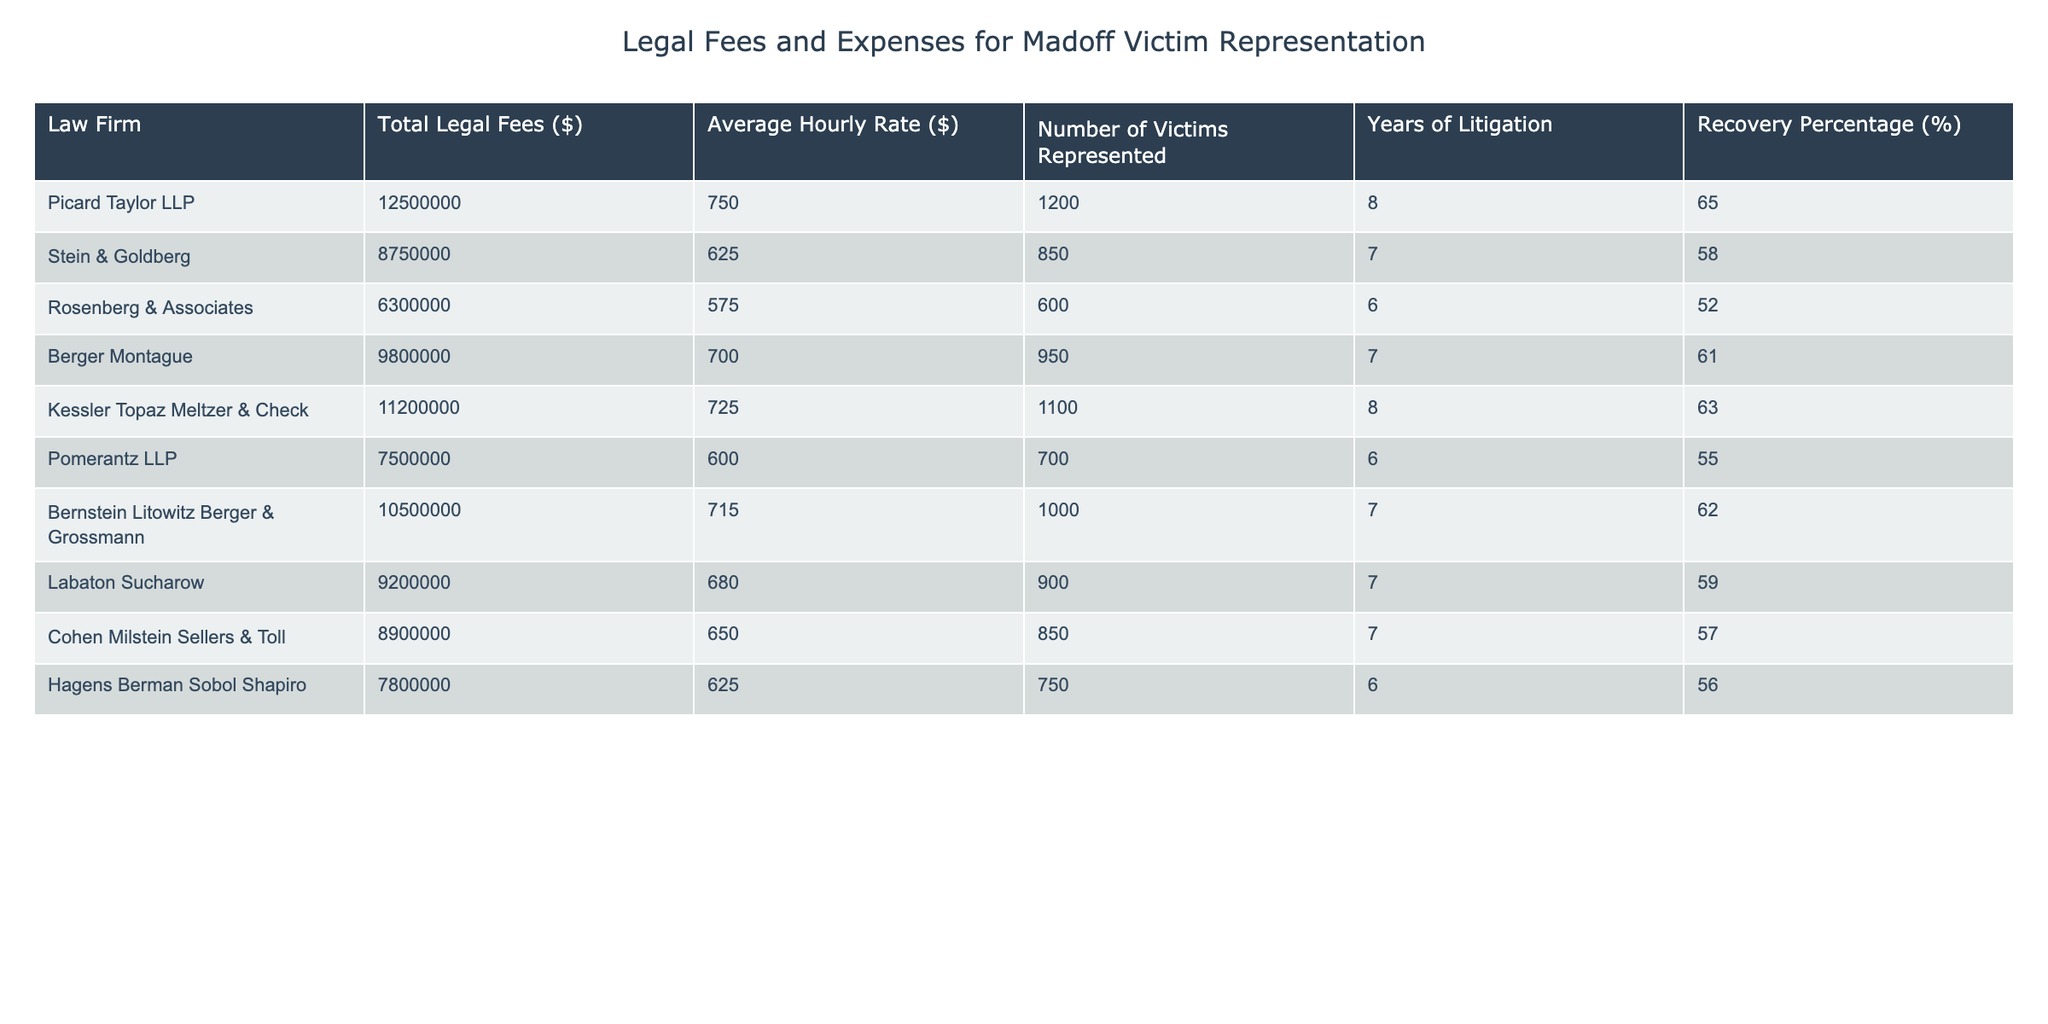What is the total legal fees charged by Picard Taylor LLP? The table shows that the Total Legal Fees charged by Picard Taylor LLP is $12,500,000.
Answer: $12,500,000 Which law firm represented the highest number of victims? By looking at the Number of Victims Represented column, Picard Taylor LLP represented the most victims with a total of 1,200.
Answer: Picard Taylor LLP What is the average hourly rate of Rosenberg & Associates? The Average Hourly Rate for Rosenberg & Associates is listed as $575 in the table.
Answer: $575 How much total legal fees did all law firms charge together? To find the total, we add the legal fees from all firms: 12,500,000 + 8,750,000 + 6,300,000 + 9,800,000 + 11,200,000 + 7,500,000 + 10,500,000 + 9,200,000 + 8,900,000 + 7,800,000, which equals $81,450,000.
Answer: $81,450,000 What percentage of recovery did Berger Montague achieve? The Recovery Percentage for Berger Montague is shown as 61% in the table.
Answer: 61% Is the average hourly rate of Kessler Topaz Meltzer & Check higher than that of Pomerantz LLP? Kessler Topaz Meltzer & Check's average hourly rate is $725 while Pomerantz LLP's is $600, so yes, Kessler's rate is higher.
Answer: Yes Which law firm charged legal fees under $8 million? Upon examining the Total Legal Fees, only Rosenberg & Associates charged $6,300,000, and Hagens Berman Sobol Shapiro charged $7,800,000, which are both below $8 million.
Answer: Rosenberg & Associates, Hagens Berman Sobol Shapiro What is the average recovery percentage of the law firms represented in the table? To find the average recovery percentage, we sum all recovery percentages (65 + 58 + 52 + 61 + 63 + 55 + 62 + 59 + 57 + 56) =  605 and divide by the number of firms (10), resulting in an average recovery percentage of 60.5%.
Answer: 60.5% If we consider the two firms with the lowest average hourly rates, what is the combined legal fee of those firms? The lowest average rates are for Pomerantz LLP ($600) and Rosenberg & Associates ($575). Their total legal fees are $7,500,000 + $6,300,000 = $13,800,000.
Answer: $13,800,000 Did any firm represent the same number of victims as Stein & Goldberg? Stein & Goldberg represented 850 victims; looking at the table, Cohen Milstein Sellers & Toll also represented 850 victims, indicating a match.
Answer: Yes 